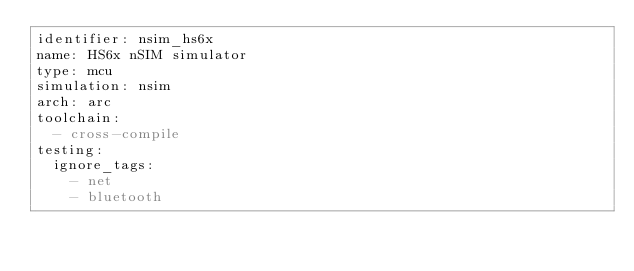<code> <loc_0><loc_0><loc_500><loc_500><_YAML_>identifier: nsim_hs6x
name: HS6x nSIM simulator
type: mcu
simulation: nsim
arch: arc
toolchain:
  - cross-compile
testing:
  ignore_tags:
    - net
    - bluetooth
</code> 